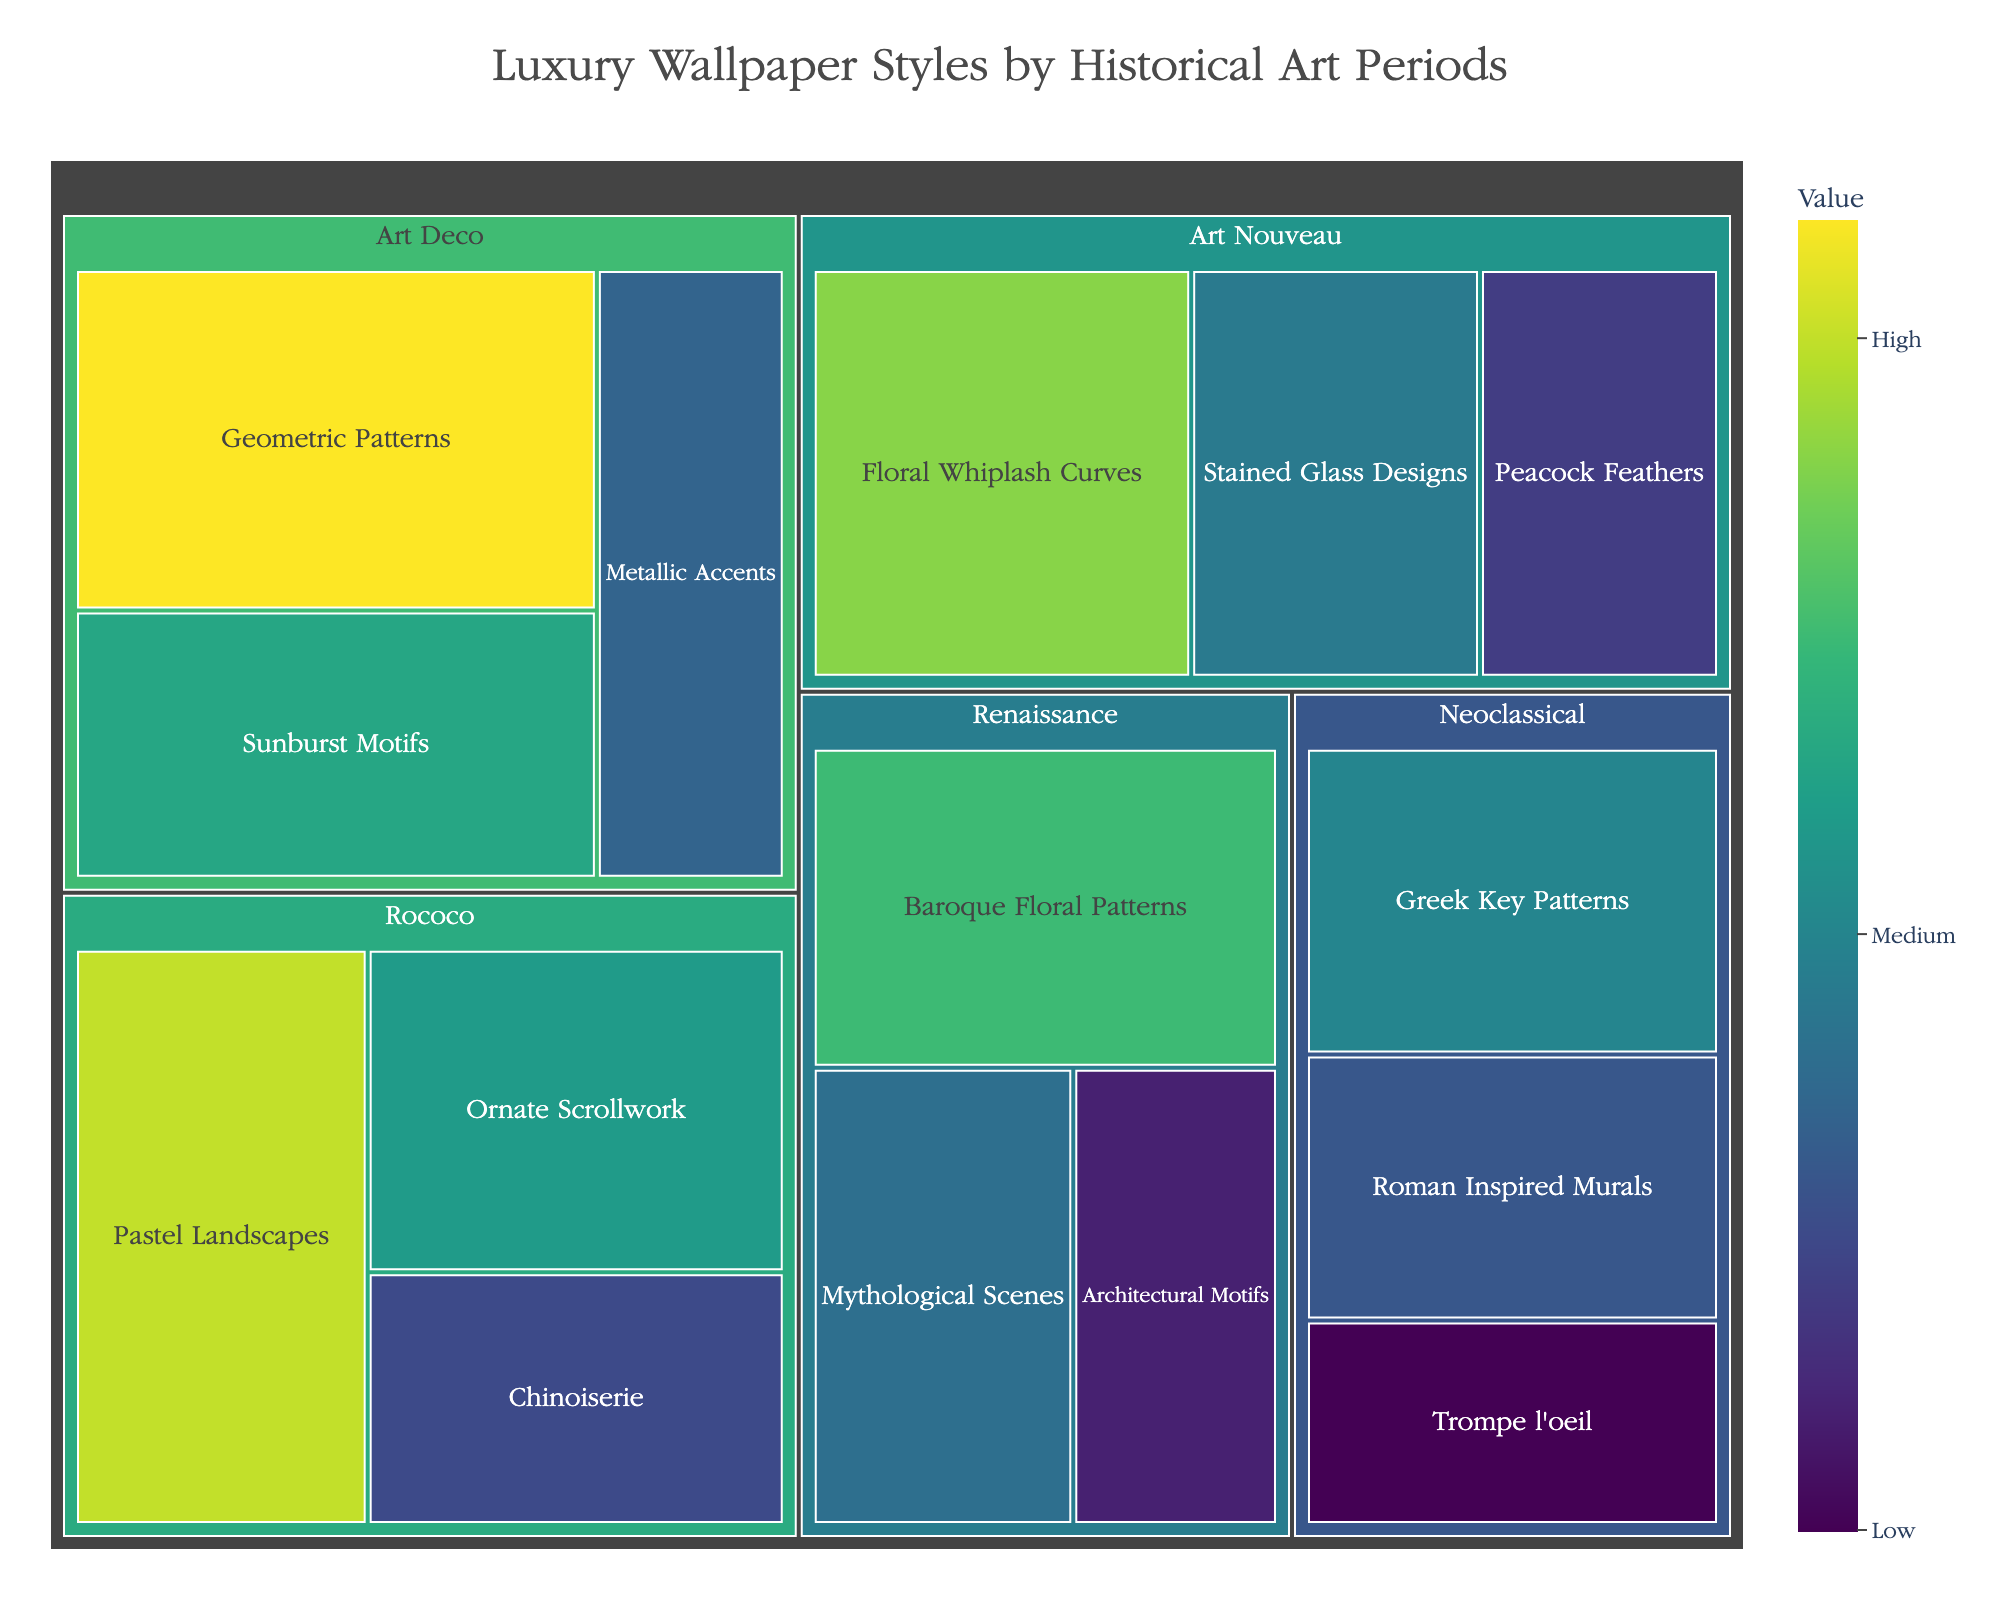What's the title of the Treemap figure? The title of a figure is usually displayed prominently at the top. In this case, it is specified in the layout parameters of the figure.
Answer: Luxury Wallpaper Styles by Historical Art Periods Which historical art period has the highest total value for its wallpaper styles? The period with the largest combined value for its subcategories will appear with the largest area in the treemap. By comparing the total values visually, the Art Deco period has the highest value (42 + 33 + 27).
Answer: Art Deco What's the color representing the highest value among the subcategories? The colormap used is Viridis, and higher values are indicated by a more yellowish color scale. The highest value of 42 will be the most yellow.
Answer: Yellowish-green Which subcategory within the Renaissance period has the lowest value? We need to consider the values of the subcategories under Renaissance. Baroque Floral Patterns (35), Mythological Scenes (28), and Architectural Motifs (22). The lowest among these is Architectural Motifs.
Answer: Architectural Motifs What is the sum of values of all subcategories under Rococo? Adding the values of Rococo subcategories: Pastel Landscapes (40) + Ornate Scrollwork (32) + Chinoiserie (25) = 97.
Answer: 97 Which subcategory within Art Nouveau has the median value? Arranging the values of Art Nouveau: Peacock Feathers (24), Stained Glass Designs (29), Floral Whiplash Curves (38). The median value among these is 29.
Answer: Stained Glass Designs How does the total value of Neoclassical compare to the total value of Renaissance? Summing up values: Neoclassical (30 + 26 + 20 = 76) vs. Renaissance (35 + 28 + 22 = 85). Renaissance has a higher total value of 85 compared to Neoclassical's 76.
Answer: Renaissance has a higher value Which historical art period features the subcategory with the second-highest individual value and what is it? The highest individual value is 42 under Art Deco. The second-highest, then, is 40 under Rococo for Pastel Landscapes.
Answer: Rococo, Pastel Landscapes What's the difference in value between the largest and smallest subcategories? The largest value is 42 under Art Deco's Geometric Patterns and the smallest is 20 under Neoclassical's Trompe l'oeil. The difference is 42 - 20.
Answer: 22 